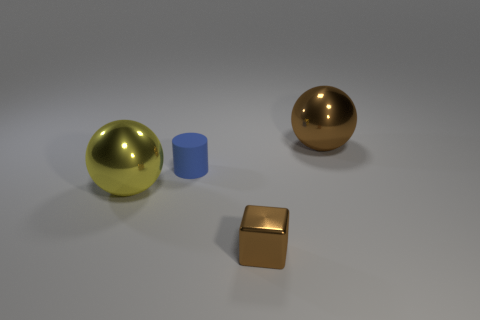Add 2 big blue metal things. How many objects exist? 6 Subtract 1 balls. How many balls are left? 1 Subtract all cylinders. How many objects are left? 3 Subtract all yellow spheres. How many spheres are left? 1 Subtract all blue cylinders. Subtract all tiny purple matte blocks. How many objects are left? 3 Add 2 metal cubes. How many metal cubes are left? 3 Add 4 tiny rubber cylinders. How many tiny rubber cylinders exist? 5 Subtract 0 purple balls. How many objects are left? 4 Subtract all blue blocks. Subtract all blue cylinders. How many blocks are left? 1 Subtract all gray blocks. How many brown balls are left? 1 